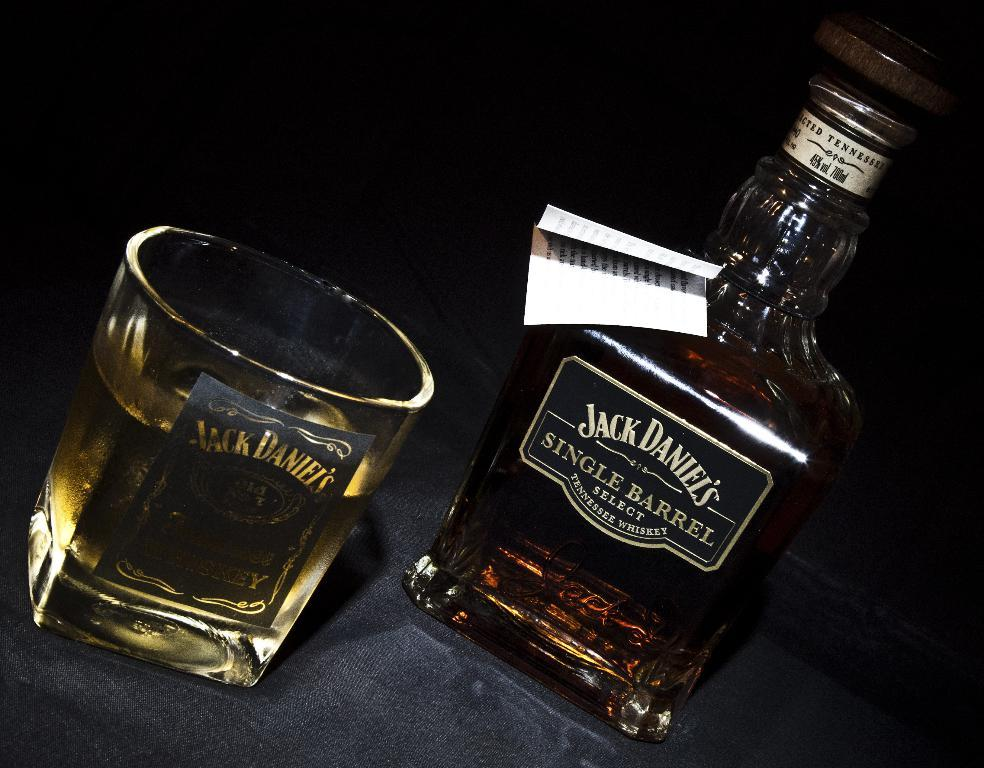<image>
Render a clear and concise summary of the photo. A bottle of Jack Daniel's Single Barrell select is next to a glass. 